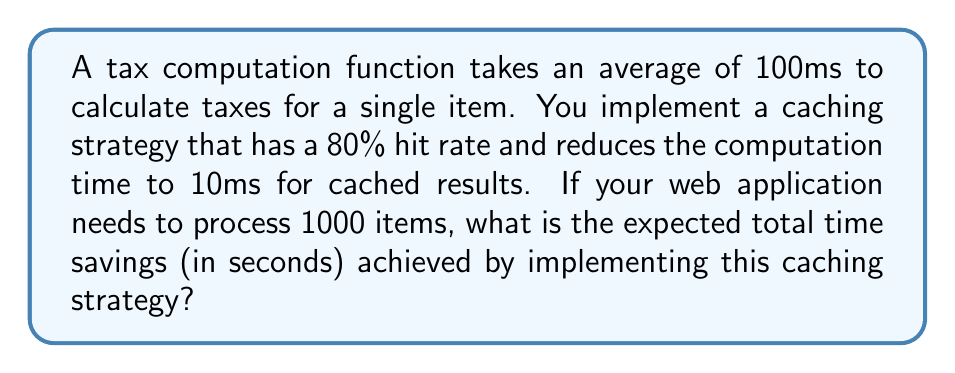Can you answer this question? Let's break this down step-by-step:

1) Without caching:
   - Time per item = 100ms
   - Total items = 1000
   - Total time = $1000 \times 100\text{ms} = 100,000\text{ms}$

2) With caching:
   - Hit rate = 80% (0.8)
   - Miss rate = 20% (0.2)
   - Time for cached result (hit) = 10ms
   - Time for non-cached result (miss) = 100ms

3) Expected time per item with caching:
   $$(0.8 \times 10\text{ms}) + (0.2 \times 100\text{ms}) = 8\text{ms} + 20\text{ms} = 28\text{ms}$$

4) Total time with caching:
   $$1000 \times 28\text{ms} = 28,000\text{ms}$$

5) Time savings:
   $$100,000\text{ms} - 28,000\text{ms} = 72,000\text{ms}$$

6) Convert to seconds:
   $$72,000\text{ms} \times \frac{1\text{s}}{1000\text{ms}} = 72\text{s}$$

Therefore, the expected total time savings is 72 seconds.
Answer: 72 seconds 